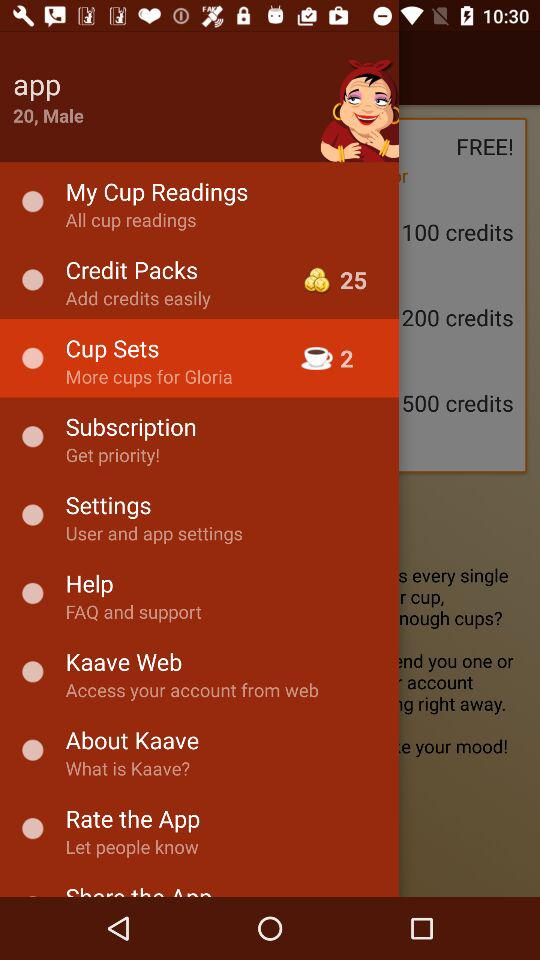How many credits are in "Credit Packs"? There are 25 credits in "Credit Packs". 